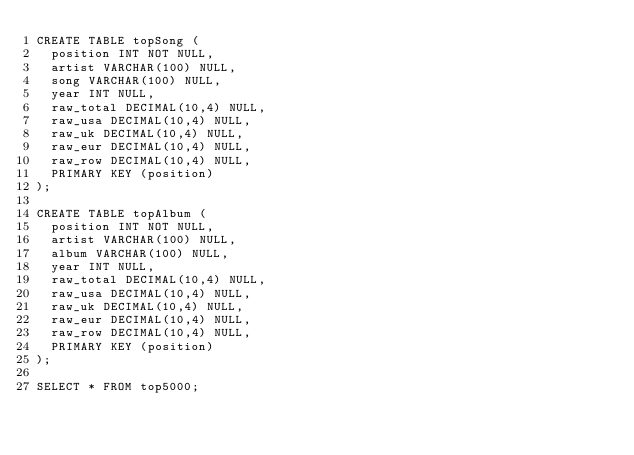Convert code to text. <code><loc_0><loc_0><loc_500><loc_500><_SQL_>CREATE TABLE topSong (
  position INT NOT NULL,
  artist VARCHAR(100) NULL,
  song VARCHAR(100) NULL,
  year INT NULL,
  raw_total DECIMAL(10,4) NULL,
  raw_usa DECIMAL(10,4) NULL,
  raw_uk DECIMAL(10,4) NULL,
  raw_eur DECIMAL(10,4) NULL,
  raw_row DECIMAL(10,4) NULL,
  PRIMARY KEY (position)
);

CREATE TABLE topAlbum (
  position INT NOT NULL,
  artist VARCHAR(100) NULL,
  album VARCHAR(100) NULL,
  year INT NULL,
  raw_total DECIMAL(10,4) NULL,
  raw_usa DECIMAL(10,4) NULL,
  raw_uk DECIMAL(10,4) NULL,
  raw_eur DECIMAL(10,4) NULL,
  raw_row DECIMAL(10,4) NULL,
  PRIMARY KEY (position)
);

SELECT * FROM top5000;</code> 